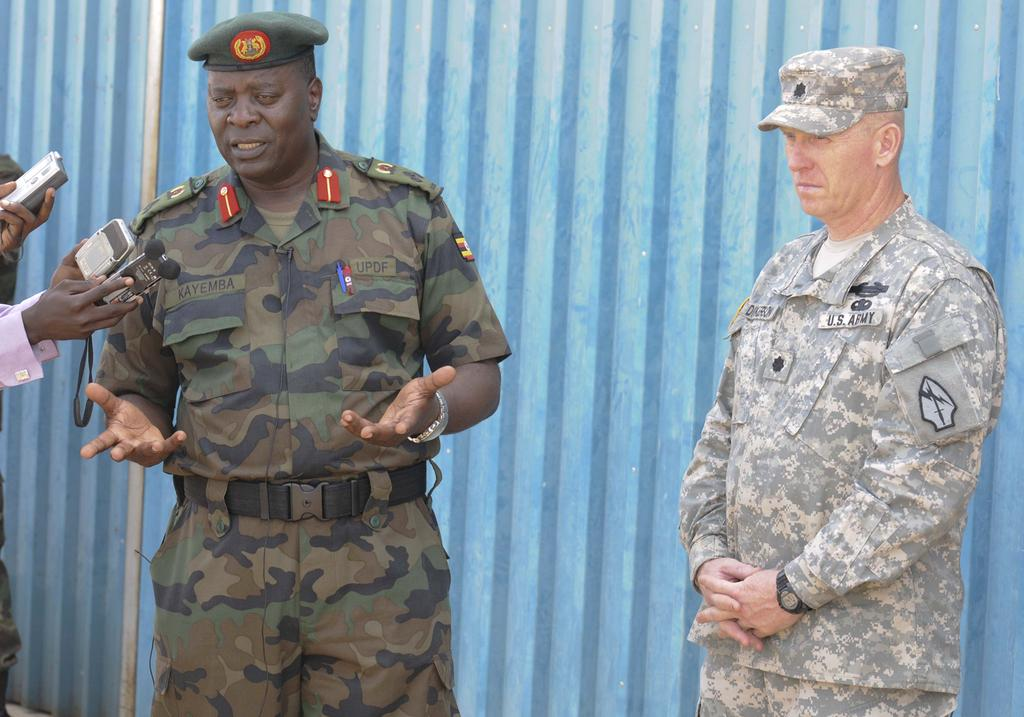Who is present in the image? There are people in the image. What are the people wearing? The people are wearing dresses. What are the people doing in the image? The people are standing. Are the people holding anything? Some people are holding objects. What can be seen in the background of the image? There is a wall visible in the image. What type of request can be heard from the people in the image? There is no indication of any requests being made in the image, as it only shows people standing and holding objects. 